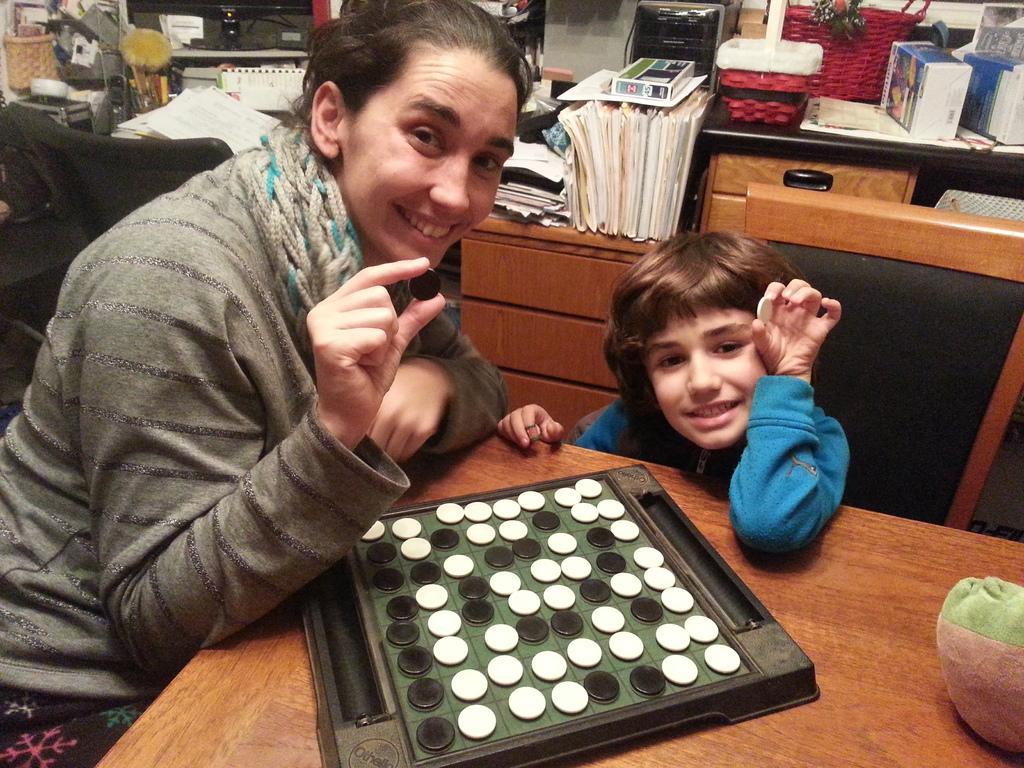How would you summarize this image in a sentence or two? There is one person sitting on the left side of this image is holding a coin. There is a kid sitting on the right side is wearing a blue color jacket. There is a table at the bottom of this image. There is some object with coins kept on to this table. There are some books and some objects are kept as we can see in the background. 